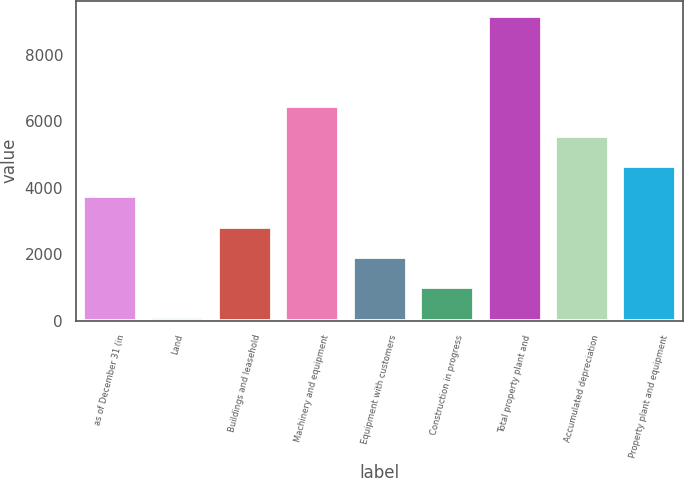Convert chart. <chart><loc_0><loc_0><loc_500><loc_500><bar_chart><fcel>as of December 31 (in<fcel>Land<fcel>Buildings and leasehold<fcel>Machinery and equipment<fcel>Equipment with customers<fcel>Construction in progress<fcel>Total property plant and<fcel>Accumulated depreciation<fcel>Property plant and equipment<nl><fcel>3735.6<fcel>118<fcel>2831.2<fcel>6448.8<fcel>1926.8<fcel>1022.4<fcel>9162<fcel>5544.4<fcel>4640<nl></chart> 